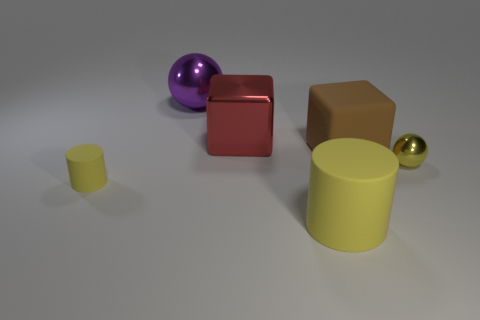Add 3 big green metal spheres. How many objects exist? 9 Subtract all cylinders. How many objects are left? 4 Add 2 large shiny things. How many large shiny things are left? 4 Add 1 big purple objects. How many big purple objects exist? 2 Subtract 1 brown blocks. How many objects are left? 5 Subtract all shiny cubes. Subtract all big shiny cubes. How many objects are left? 4 